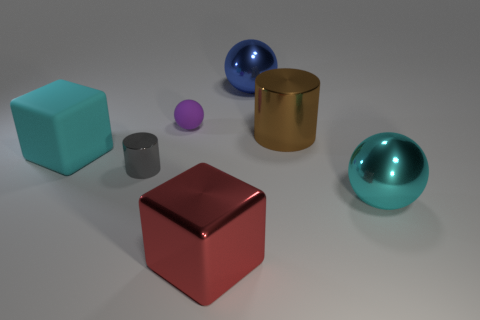There is a gray cylinder; are there any small cylinders on the right side of it?
Ensure brevity in your answer.  No. The shiny thing that is left of the big shiny cylinder and in front of the tiny gray cylinder is what color?
Keep it short and to the point. Red. Is there a rubber thing of the same color as the large metal cylinder?
Give a very brief answer. No. Is the material of the cyan thing right of the small purple matte ball the same as the cylinder on the right side of the small gray thing?
Your response must be concise. Yes. There is a cyan thing to the left of the tiny purple matte thing; how big is it?
Ensure brevity in your answer.  Large. How big is the shiny block?
Offer a terse response. Large. There is a cylinder on the left side of the big sphere left of the large cyan thing in front of the gray shiny object; what size is it?
Provide a succinct answer. Small. Is there a blue cylinder made of the same material as the big red object?
Give a very brief answer. No. What is the shape of the large blue shiny thing?
Offer a terse response. Sphere. There is a block that is made of the same material as the small cylinder; what color is it?
Ensure brevity in your answer.  Red. 